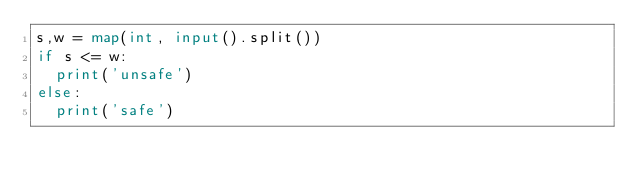<code> <loc_0><loc_0><loc_500><loc_500><_Python_>s,w = map(int, input().split())
if s <= w:
  print('unsafe')
else:
  print('safe')</code> 